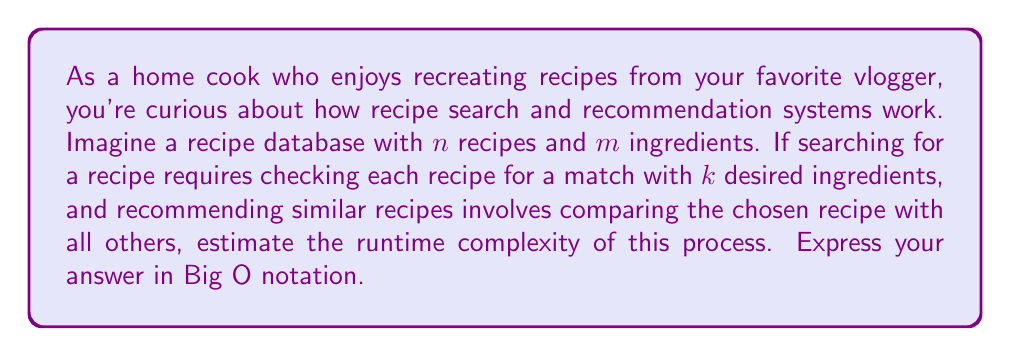Show me your answer to this math problem. Let's break this down step-by-step:

1) Searching for a recipe:
   - We need to check each of the $n$ recipes.
   - For each recipe, we compare $k$ desired ingredients with the recipe's ingredients.
   - Assuming each comparison takes constant time, this step has a complexity of $O(nk)$.

2) Recommending similar recipes:
   - Once a recipe is found, we need to compare it with all other recipes to find similar ones.
   - This requires comparing the chosen recipe with the remaining $(n-1)$ recipes.
   - Each comparison involves checking all $m$ ingredients.
   - This step has a complexity of $O(nm)$.

3) Total process:
   - The total runtime is the sum of these two steps.
   - $O(nk + nm)$

4) Simplifying:
   - Since $k$ (number of desired ingredients) is typically much smaller than $m$ (total number of ingredients in the database), we can simplify this to $O(nm)$.

Therefore, the overall runtime complexity of this recipe search and recommendation process is $O(nm)$.
Answer: $O(nm)$ 